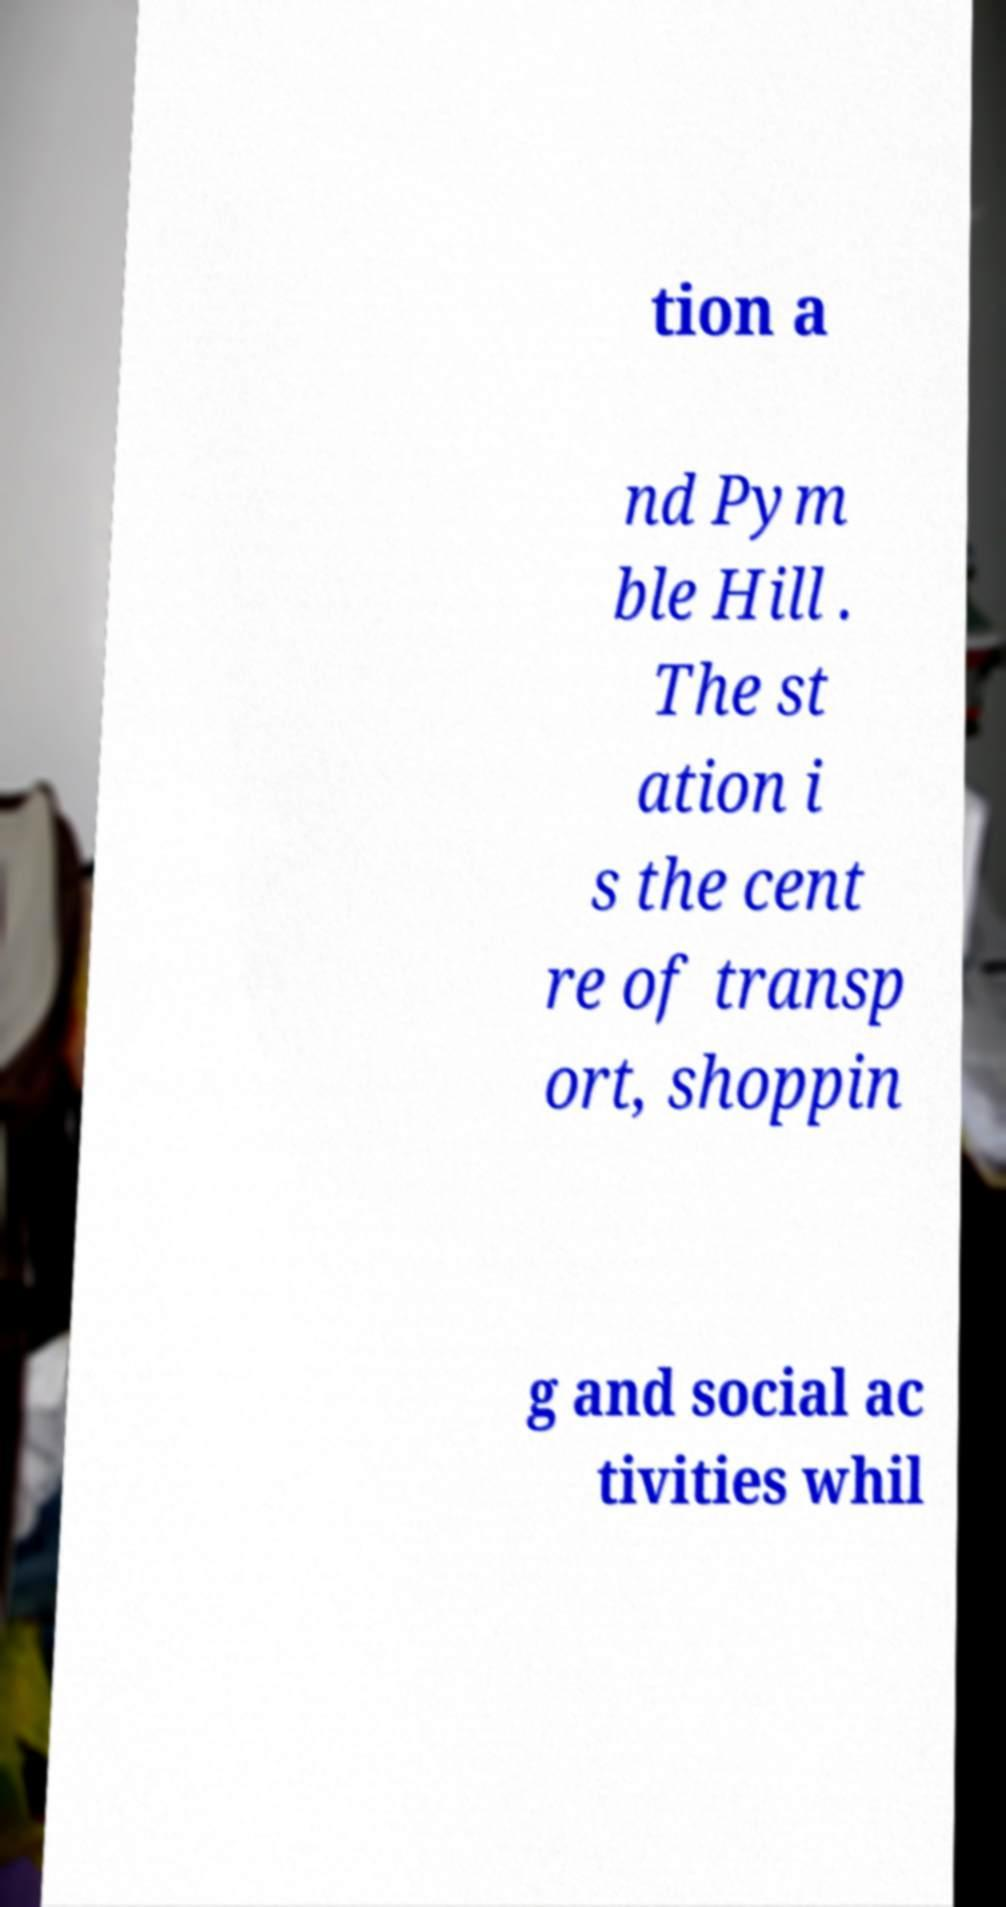I need the written content from this picture converted into text. Can you do that? tion a nd Pym ble Hill . The st ation i s the cent re of transp ort, shoppin g and social ac tivities whil 